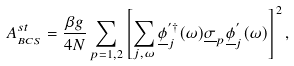<formula> <loc_0><loc_0><loc_500><loc_500>A _ { _ { B C S } } ^ { s t } = \frac { \beta g } { 4 N } \sum _ { p = 1 , 2 } \left [ \sum _ { j , \omega } \underline { \phi } _ { j } ^ { ^ { \prime } \dag } ( \omega ) \underline { \sigma } _ { p } \underline { \phi } ^ { ^ { \prime } } _ { j } ( \omega ) \right ] ^ { 2 } ,</formula> 